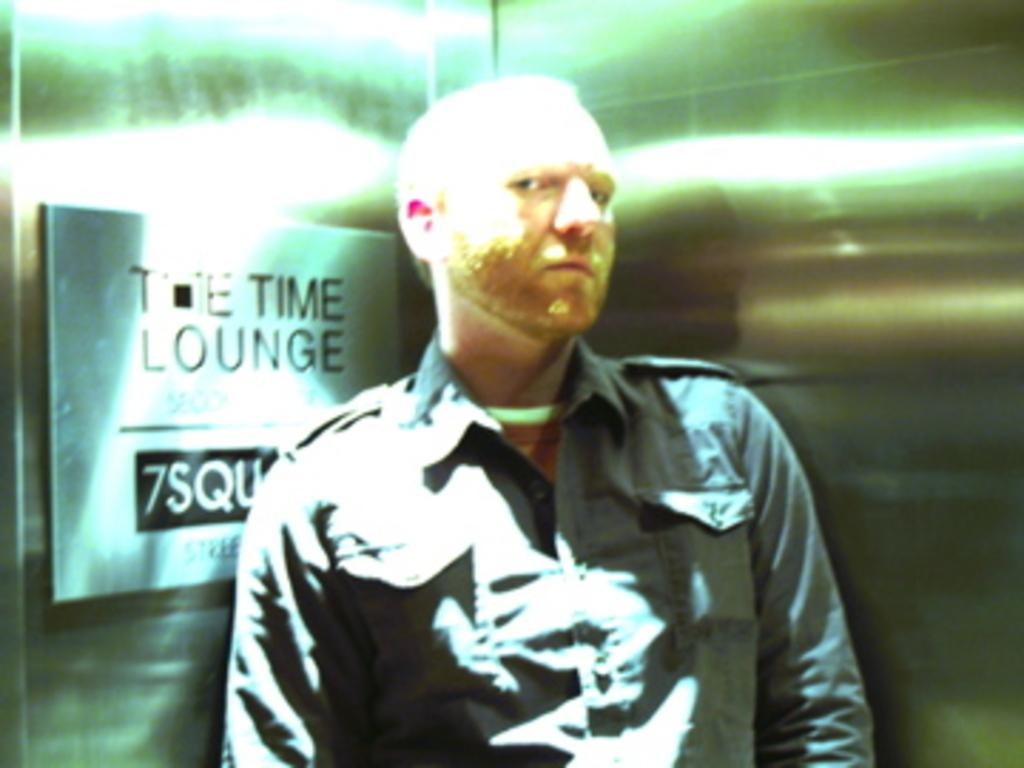What is the main subject in the image? There is a man standing in the image. What else can be seen in the image besides the man? There is a metal object in the image. Can you describe the location of the metal object? The metal object is attached to a steel wall. Is there any text or symbols on the metal object? Yes, there is writing on the metal object. How many cattle are visible in the image? There are no cattle present in the image. What type of whistle is the man using in the image? There is no whistle visible in the image. 